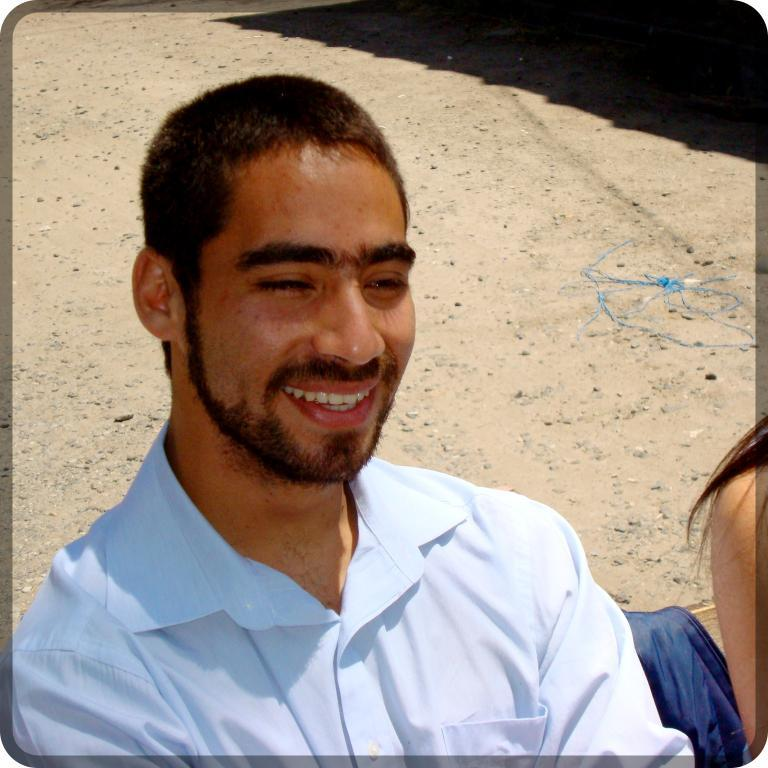Who are the people in the image? There is a man and a woman in the image. What are the man and woman doing in the image? Both the man and woman are sitting on a bench. Can you describe the background of the image? There is a shadow in the background of the image. What type of animal can be seen in the image? There is no animal present in the image. What year is the image taken? The year the image was taken is not mentioned in the provided facts. 